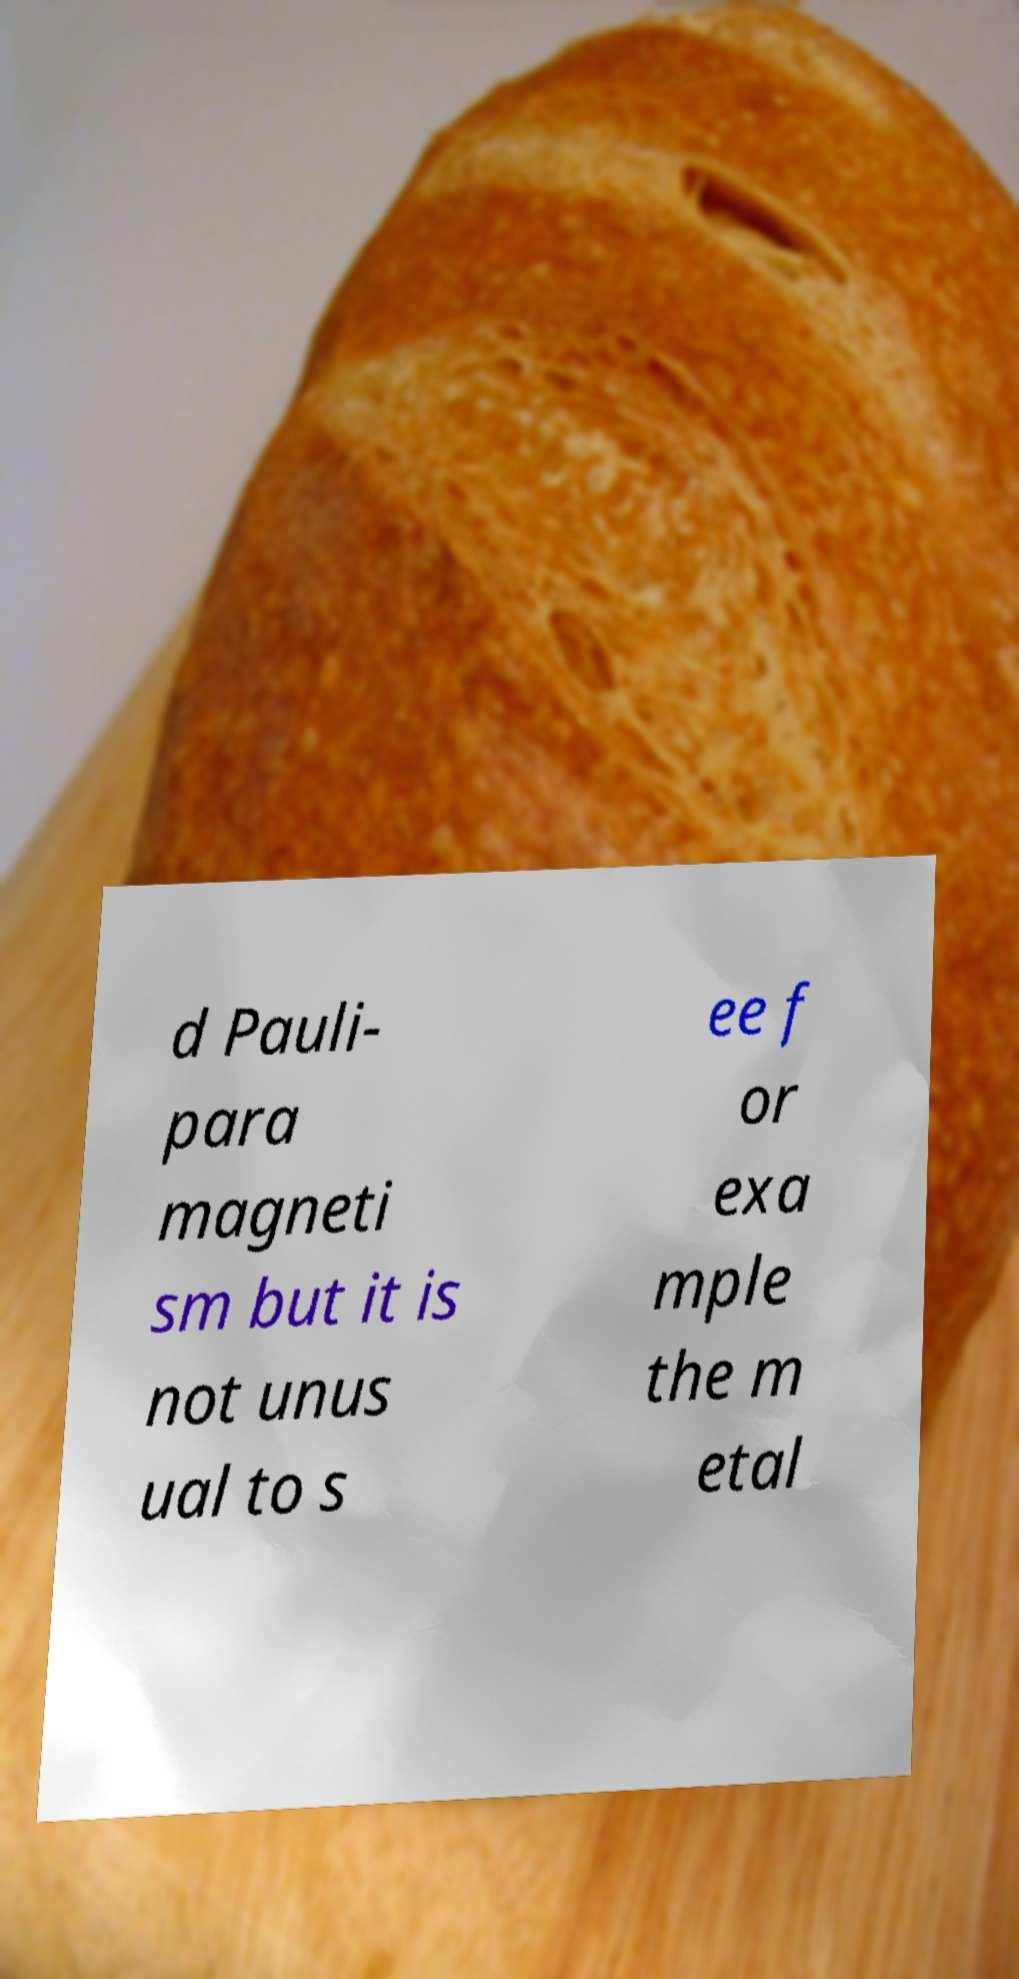Could you assist in decoding the text presented in this image and type it out clearly? d Pauli- para magneti sm but it is not unus ual to s ee f or exa mple the m etal 